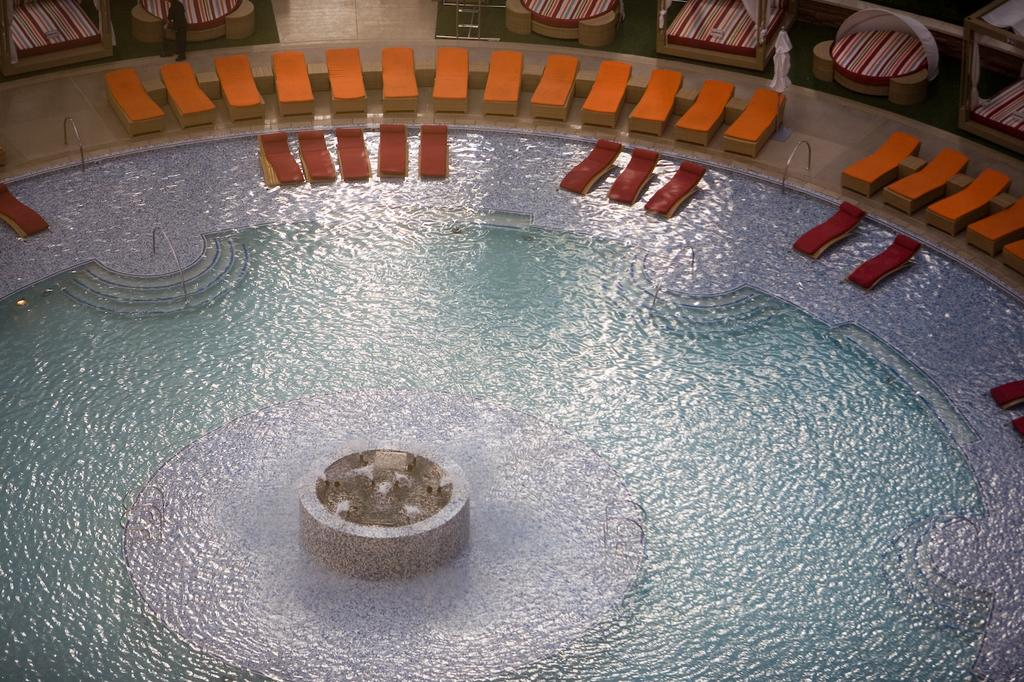What is the main feature in the center of the image? There is a swimming pool in the center of the image. What type of furniture is present in the image? There are relax outdoor chairs in the image. Are there any architectural elements visible in the image? Yes, staircases are present in the image. Can you describe the presence of people in the image? There is at least one person standing in the image. What is the price of the ladybug seen in the image? There is no ladybug present in the image, so it is not possible to determine its price. 